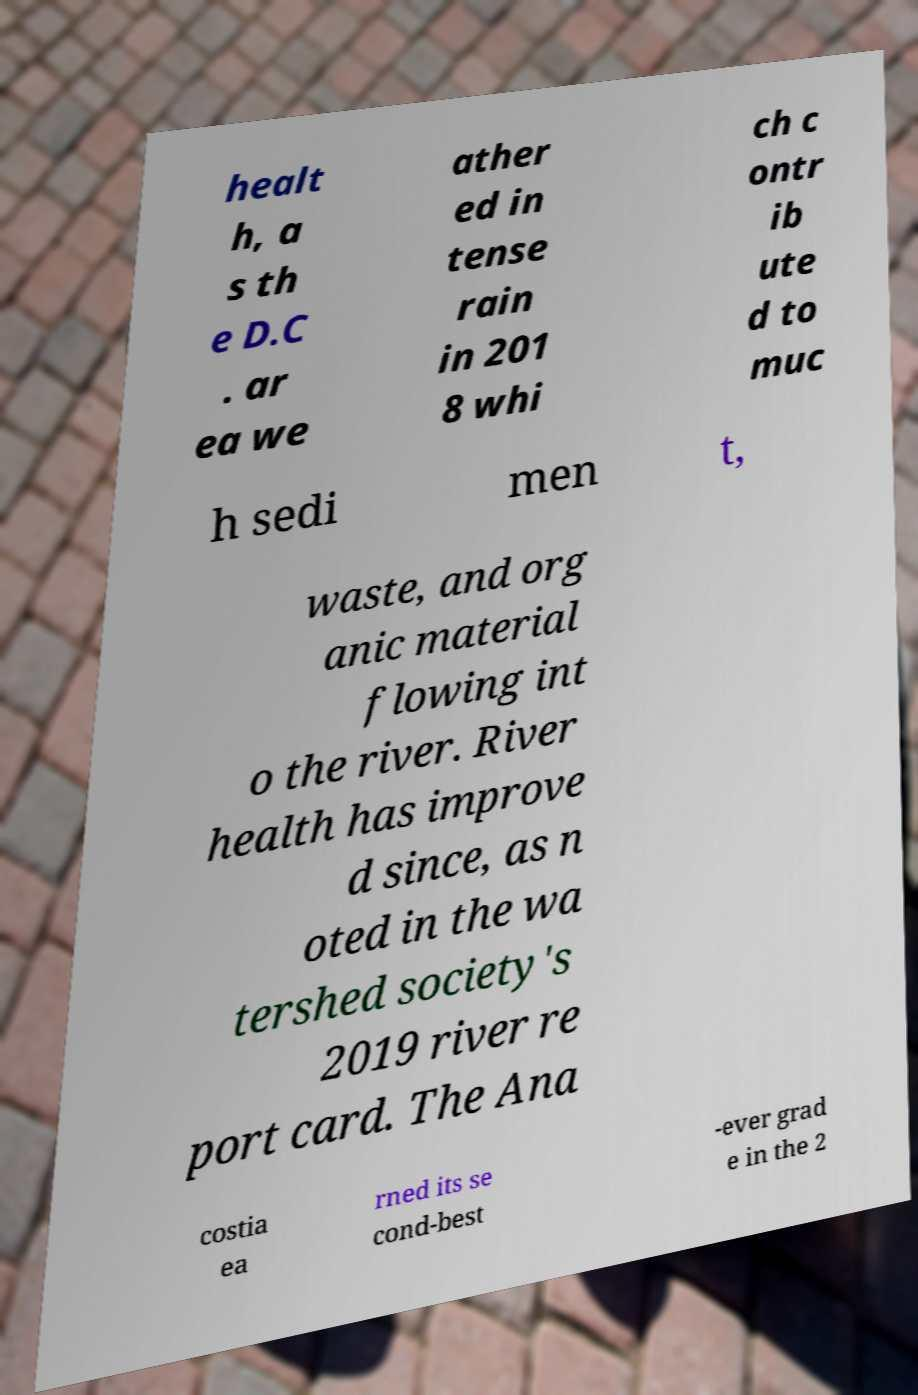What messages or text are displayed in this image? I need them in a readable, typed format. healt h, a s th e D.C . ar ea we ather ed in tense rain in 201 8 whi ch c ontr ib ute d to muc h sedi men t, waste, and org anic material flowing int o the river. River health has improve d since, as n oted in the wa tershed society's 2019 river re port card. The Ana costia ea rned its se cond-best -ever grad e in the 2 